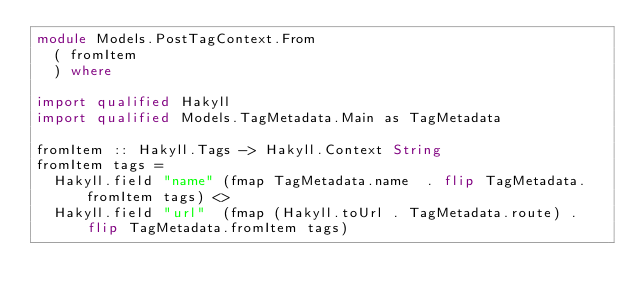<code> <loc_0><loc_0><loc_500><loc_500><_Haskell_>module Models.PostTagContext.From
  ( fromItem
  ) where

import qualified Hakyll
import qualified Models.TagMetadata.Main as TagMetadata

fromItem :: Hakyll.Tags -> Hakyll.Context String
fromItem tags =
  Hakyll.field "name" (fmap TagMetadata.name  . flip TagMetadata.fromItem tags) <>
  Hakyll.field "url"  (fmap (Hakyll.toUrl . TagMetadata.route) . flip TagMetadata.fromItem tags)

</code> 